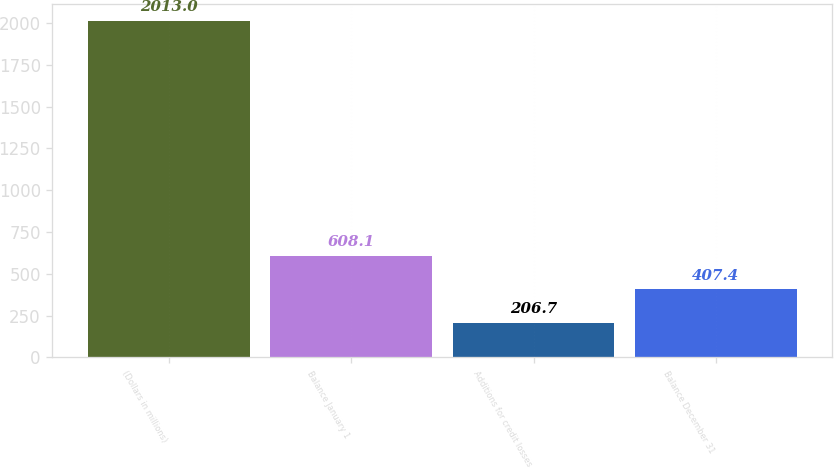Convert chart to OTSL. <chart><loc_0><loc_0><loc_500><loc_500><bar_chart><fcel>(Dollars in millions)<fcel>Balance January 1<fcel>Additions for credit losses<fcel>Balance December 31<nl><fcel>2013<fcel>608.1<fcel>206.7<fcel>407.4<nl></chart> 